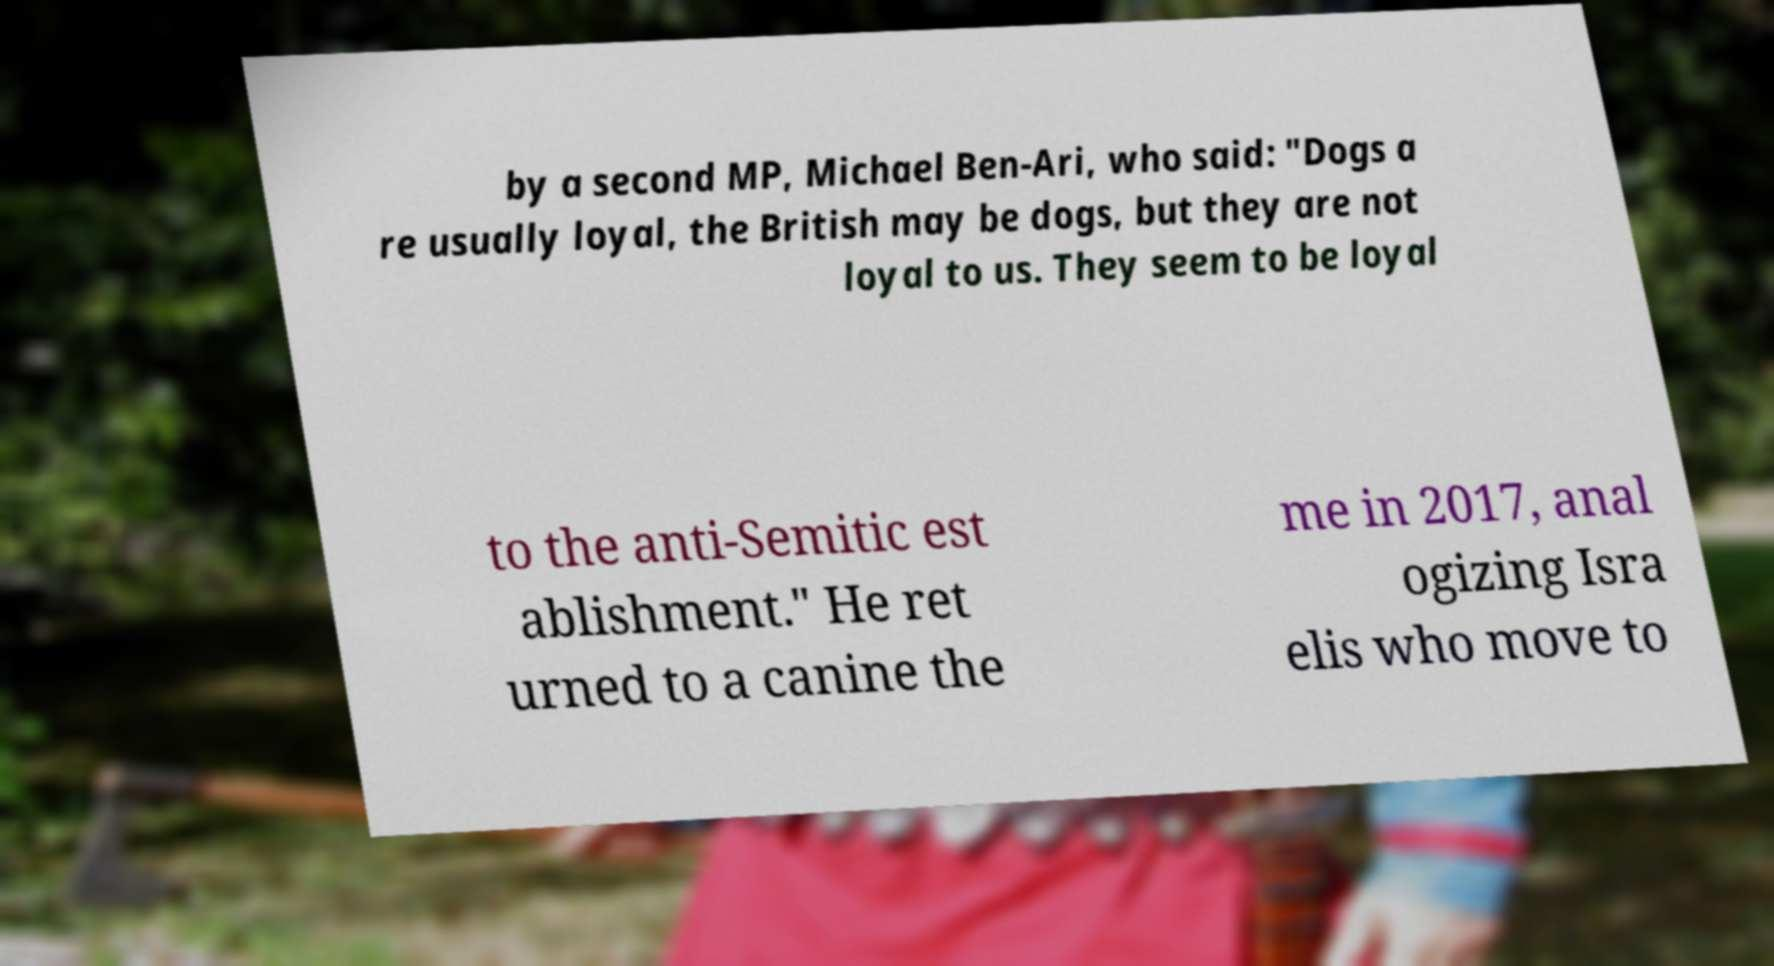What messages or text are displayed in this image? I need them in a readable, typed format. by a second MP, Michael Ben-Ari, who said: "Dogs a re usually loyal, the British may be dogs, but they are not loyal to us. They seem to be loyal to the anti-Semitic est ablishment." He ret urned to a canine the me in 2017, anal ogizing Isra elis who move to 